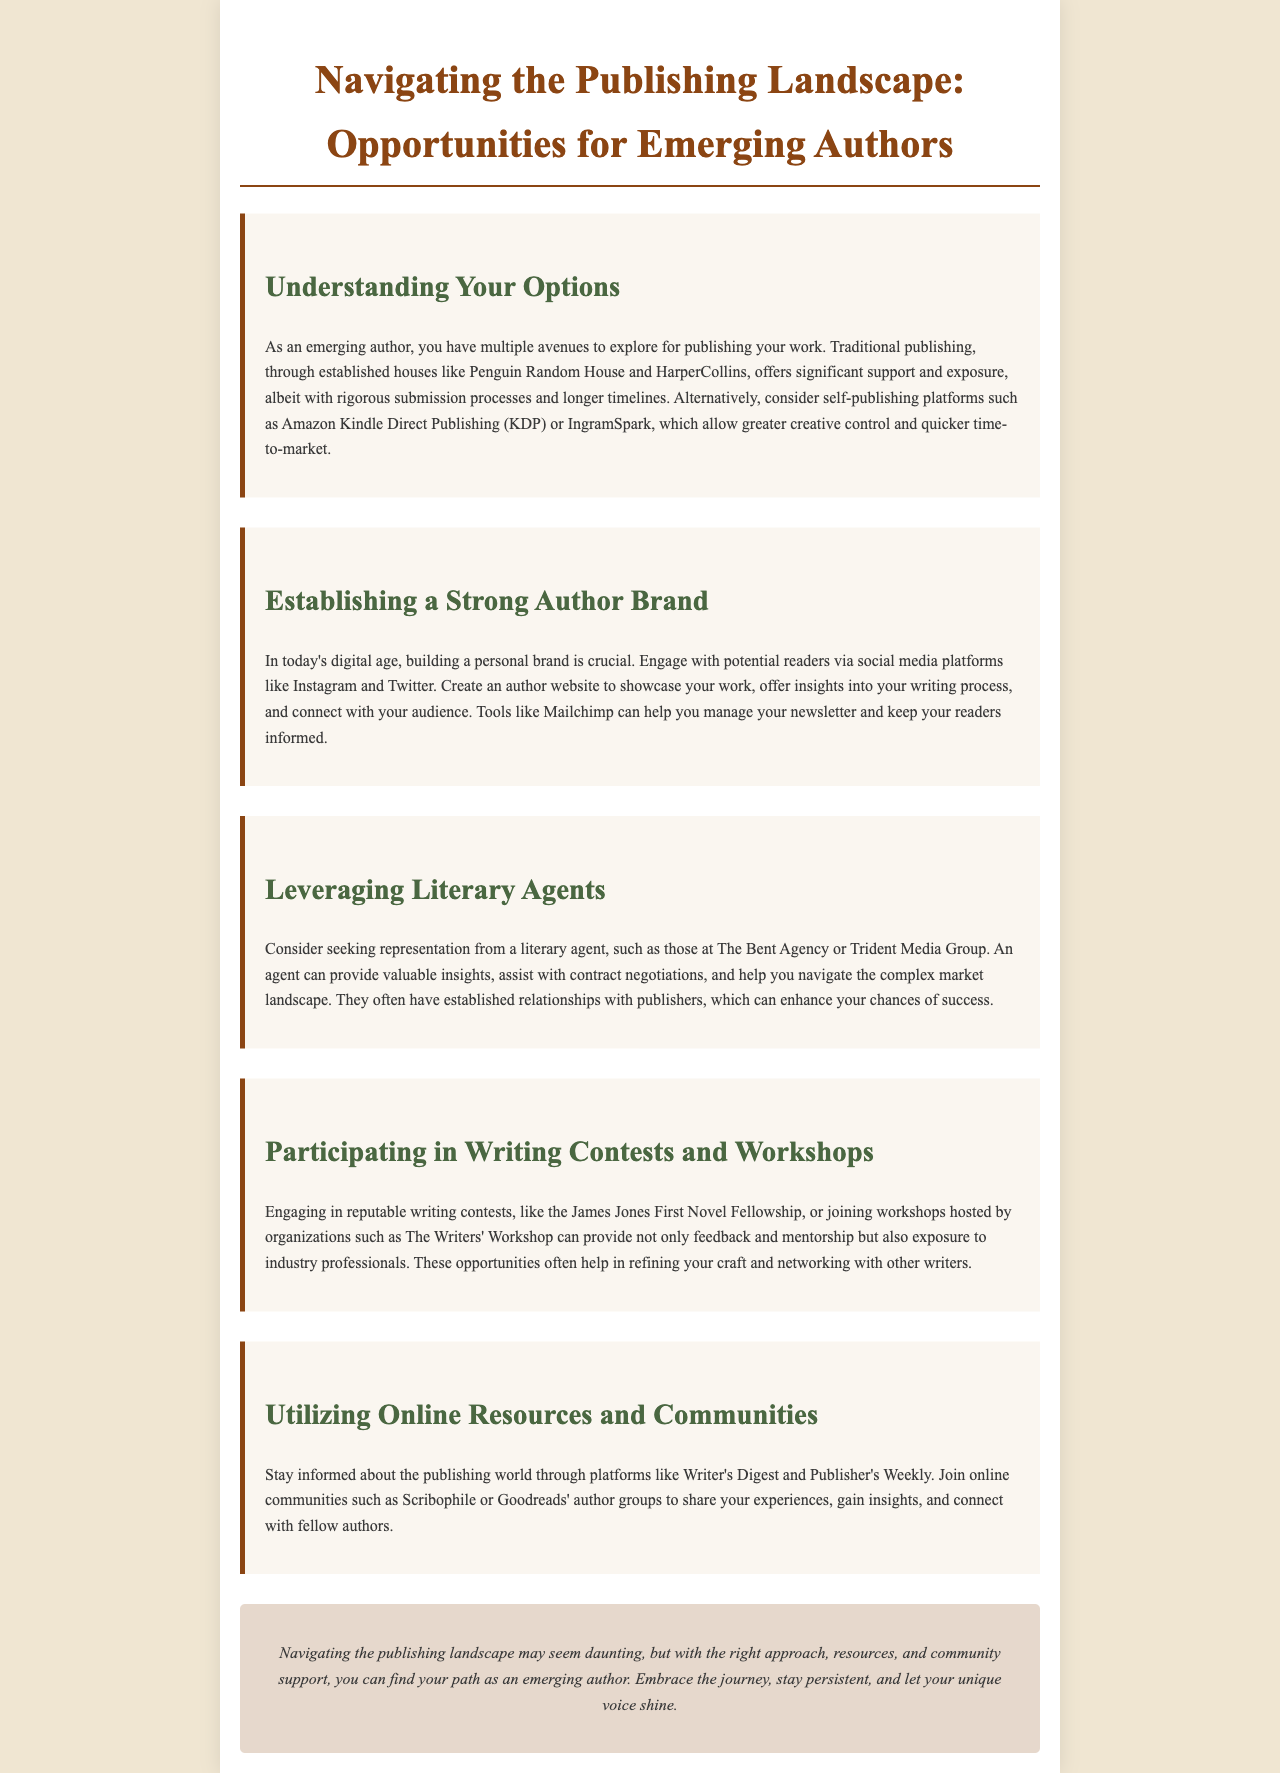What are two options for publishing your work? The document mentions traditional publishing and self-publishing platforms.
Answer: traditional publishing, self-publishing platforms Name a traditional publishing house mentioned in the document. The document lists Penguin Random House and HarperCollins as examples.
Answer: Penguin Random House What social media platforms should authors engage with? The brochure suggests Instagram and Twitter as platforms for engagement.
Answer: Instagram, Twitter Who can provide valuable insights and contract assistance? The document states that literary agents are the professionals who can assist in this manner.
Answer: literary agents What is one writing contest mentioned in the brochure? The James Jones First Novel Fellowship is the contest highlighted in the document.
Answer: James Jones First Novel Fellowship What platform can help manage newsletters? Mailchimp is recommended for managing newsletters in the brochure.
Answer: Mailchimp Which online community is suggested for authors to share experiences? The document mentions Scribophile as an online community for authors.
Answer: Scribophile What is a key benefit of participating in workshops? Engaging in workshops provides feedback, mentorship, and exposure to industry professionals.
Answer: feedback, mentorship, exposure to industry professionals What type of resources can writers utilize to stay informed? The document suggests platforms like Writer's Digest and Publisher's Weekly for information.
Answer: Writer's Digest, Publisher's Weekly 